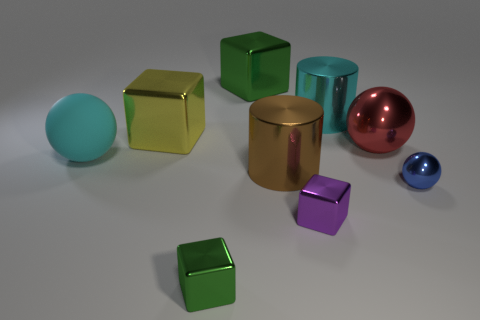Add 1 big yellow metal blocks. How many objects exist? 10 Subtract all balls. How many objects are left? 6 Add 6 small green shiny objects. How many small green shiny objects are left? 7 Add 5 brown shiny blocks. How many brown shiny blocks exist? 5 Subtract 0 blue cylinders. How many objects are left? 9 Subtract all small brown objects. Subtract all blue metal spheres. How many objects are left? 8 